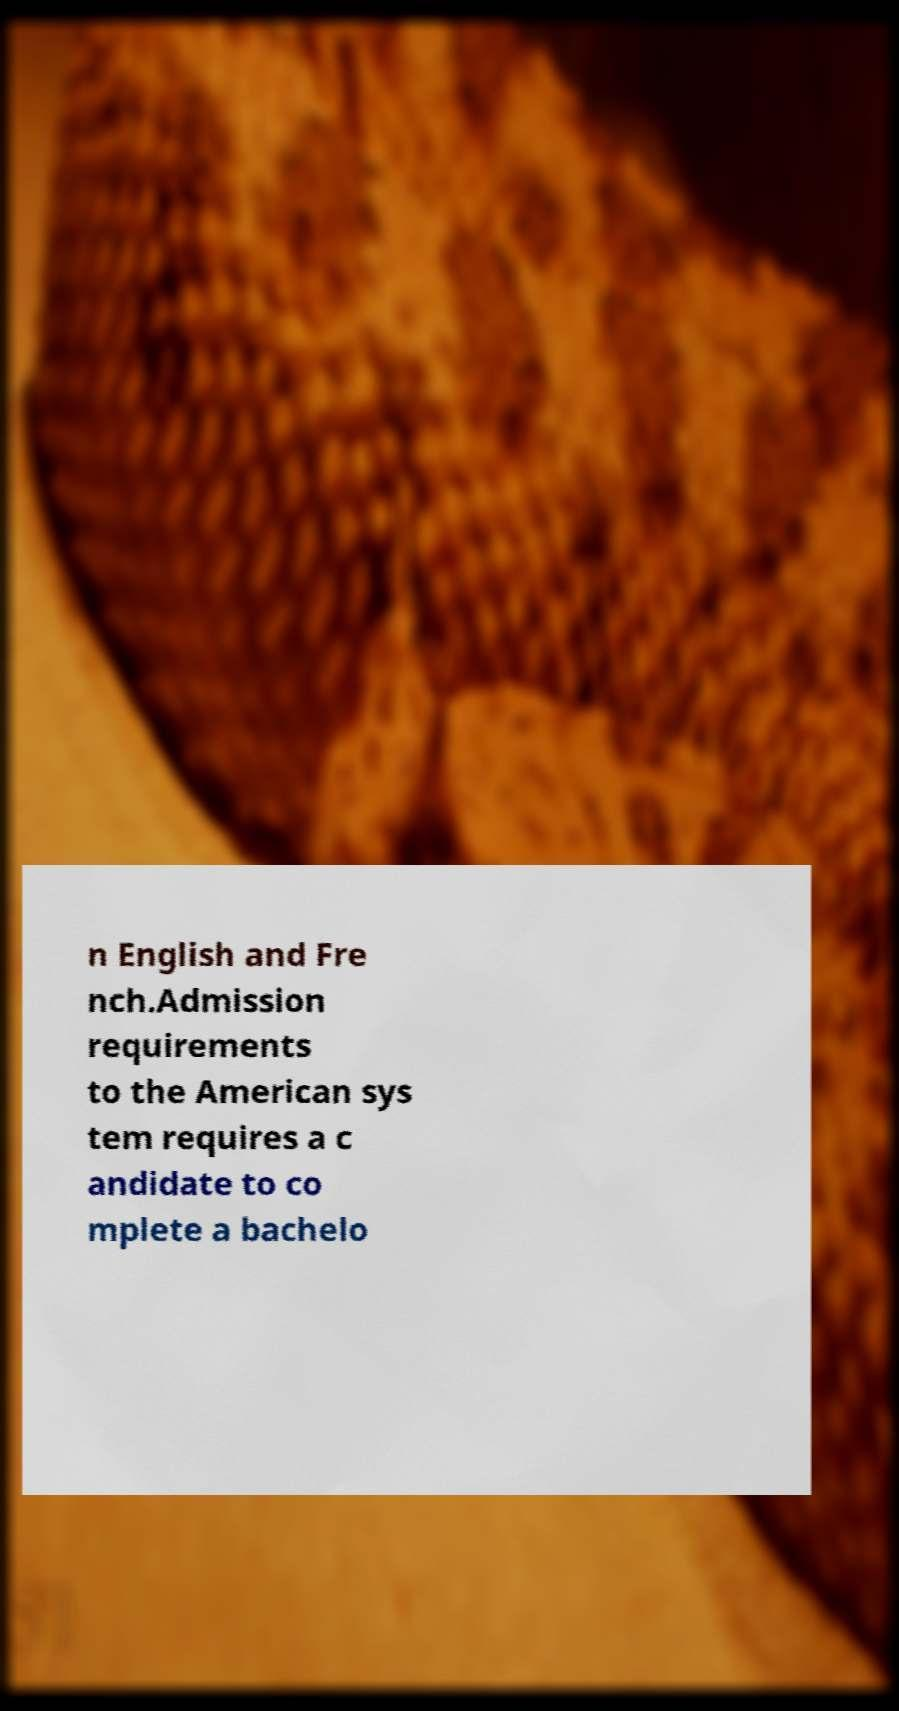What messages or text are displayed in this image? I need them in a readable, typed format. n English and Fre nch.Admission requirements to the American sys tem requires a c andidate to co mplete a bachelo 